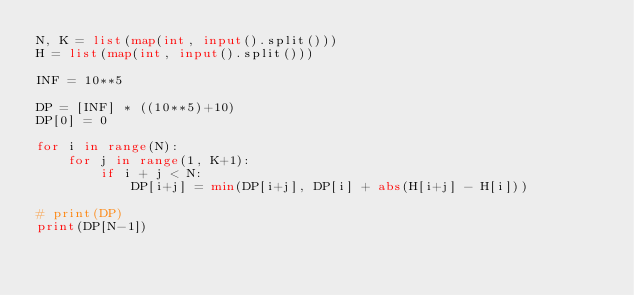<code> <loc_0><loc_0><loc_500><loc_500><_Python_>N, K = list(map(int, input().split()))
H = list(map(int, input().split()))

INF = 10**5

DP = [INF] * ((10**5)+10)
DP[0] = 0

for i in range(N):
    for j in range(1, K+1):
        if i + j < N:
            DP[i+j] = min(DP[i+j], DP[i] + abs(H[i+j] - H[i]))

# print(DP)
print(DP[N-1])</code> 